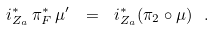Convert formula to latex. <formula><loc_0><loc_0><loc_500><loc_500>i _ { Z _ { a } } ^ { \ast } \, \pi _ { F } ^ { \ast } \, \mu ^ { \prime } \ = \ i _ { Z _ { a } } ^ { \ast } ( \pi _ { 2 } \circ \mu ) \ .</formula> 